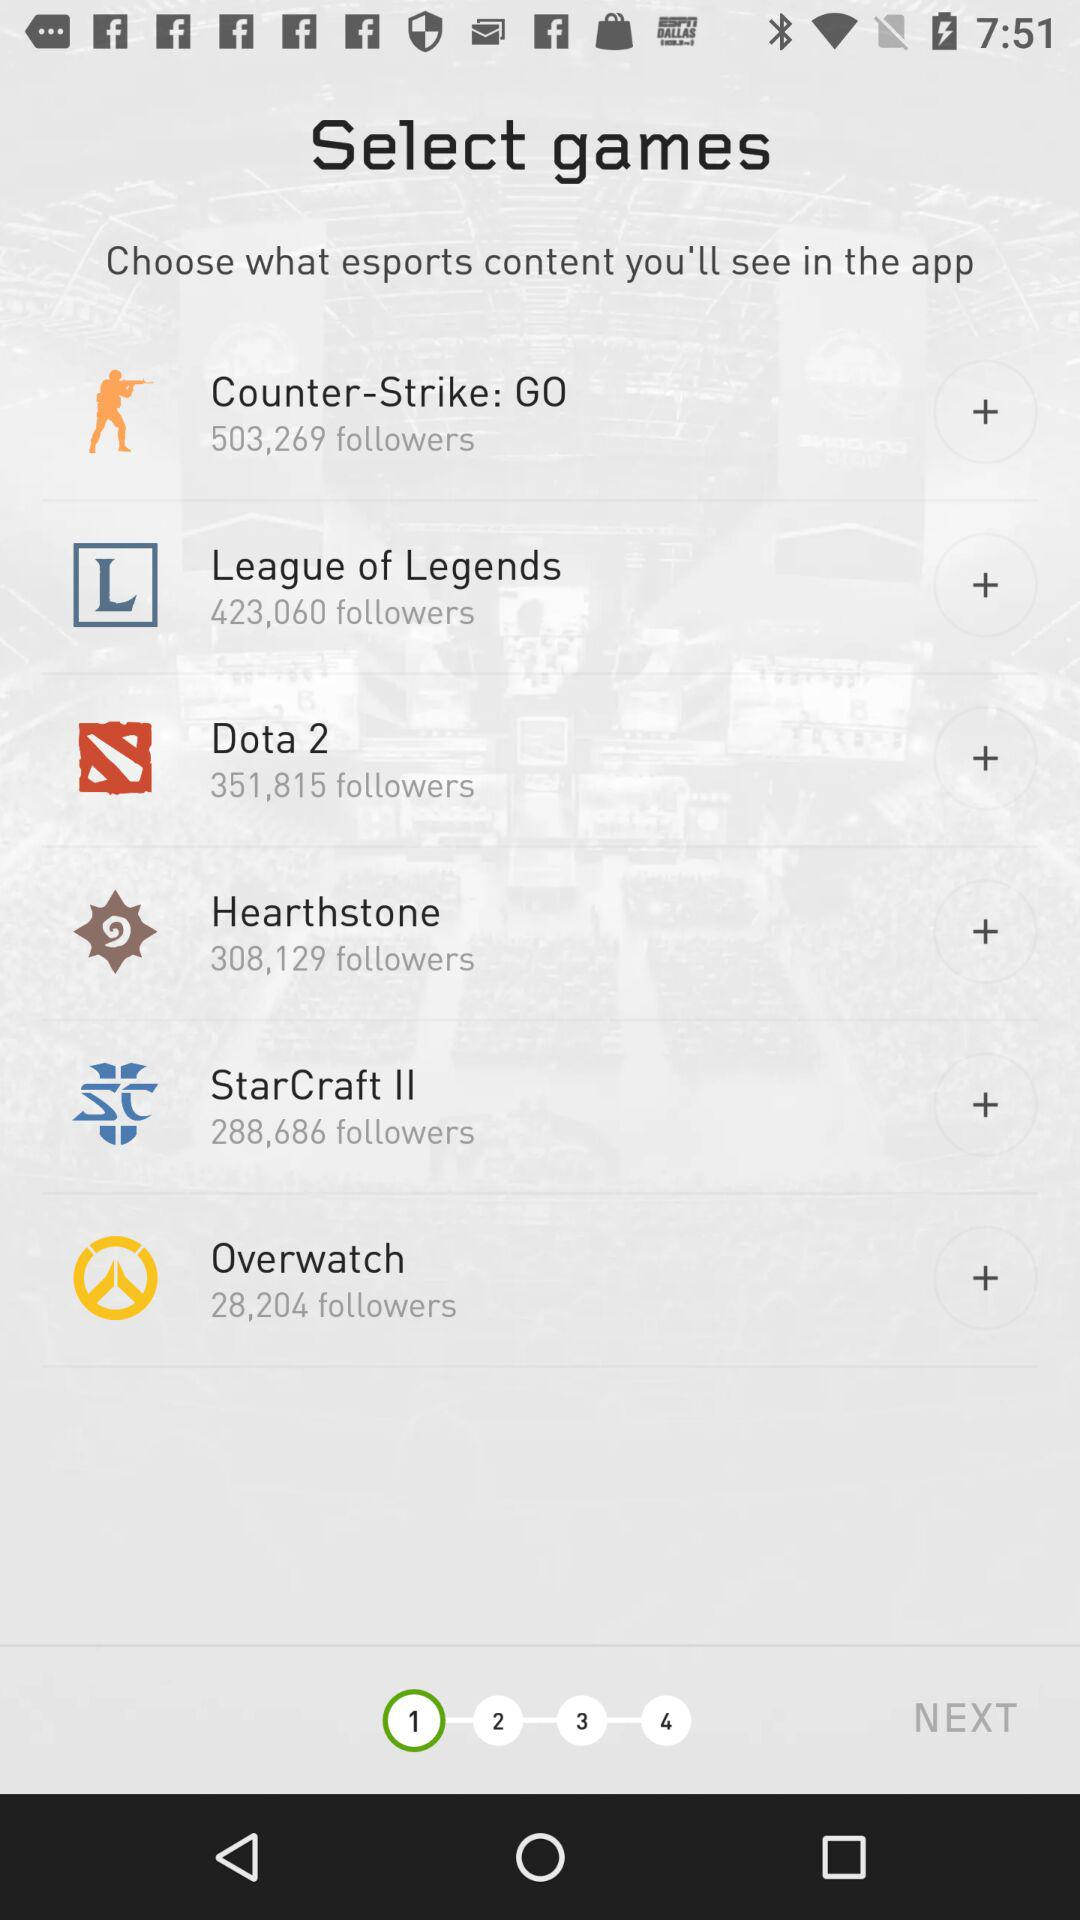Which game has 351,815 followers? The game is "Dota 2". 